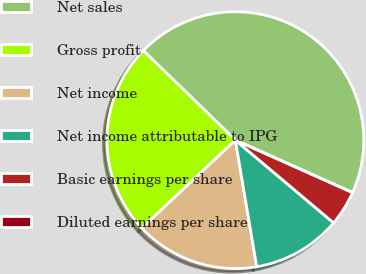Convert chart to OTSL. <chart><loc_0><loc_0><loc_500><loc_500><pie_chart><fcel>Net sales<fcel>Gross profit<fcel>Net income<fcel>Net income attributable to IPG<fcel>Basic earnings per share<fcel>Diluted earnings per share<nl><fcel>44.42%<fcel>24.3%<fcel>15.64%<fcel>11.2%<fcel>4.44%<fcel>0.0%<nl></chart> 